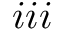<formula> <loc_0><loc_0><loc_500><loc_500>i i i</formula> 